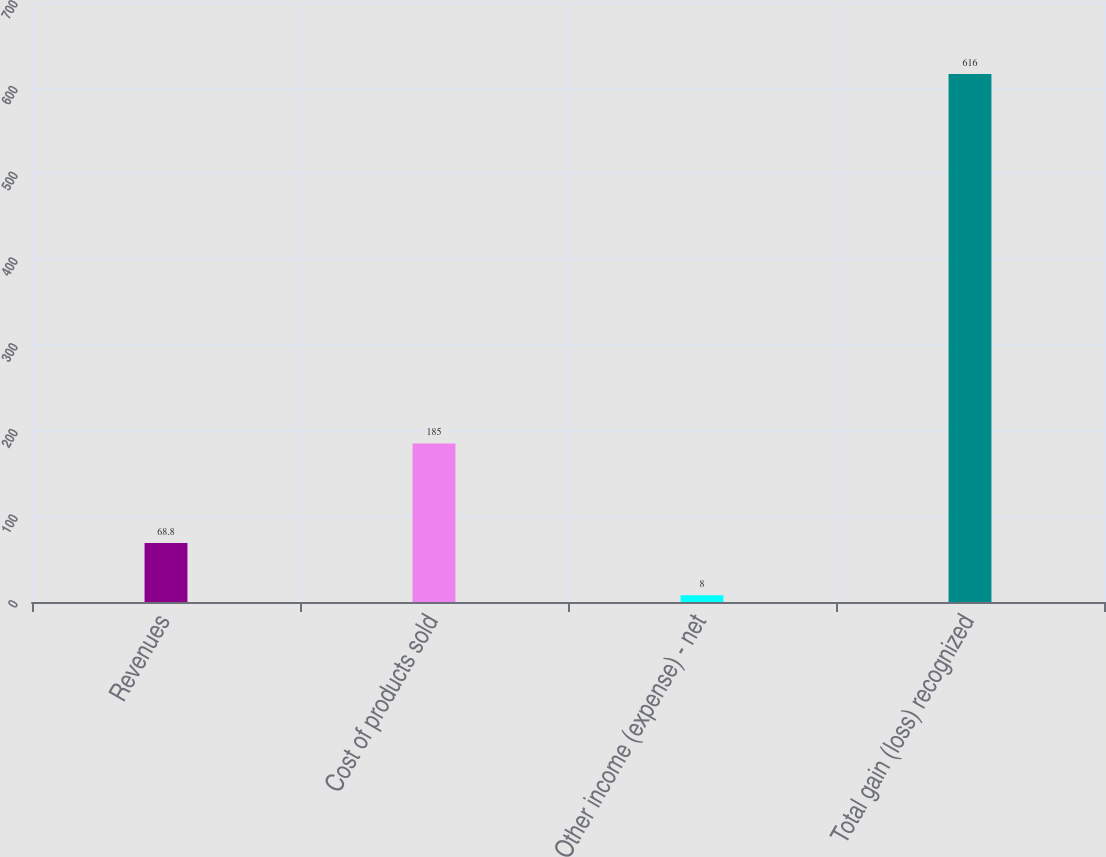Convert chart. <chart><loc_0><loc_0><loc_500><loc_500><bar_chart><fcel>Revenues<fcel>Cost of products sold<fcel>Other income (expense) - net<fcel>Total gain (loss) recognized<nl><fcel>68.8<fcel>185<fcel>8<fcel>616<nl></chart> 